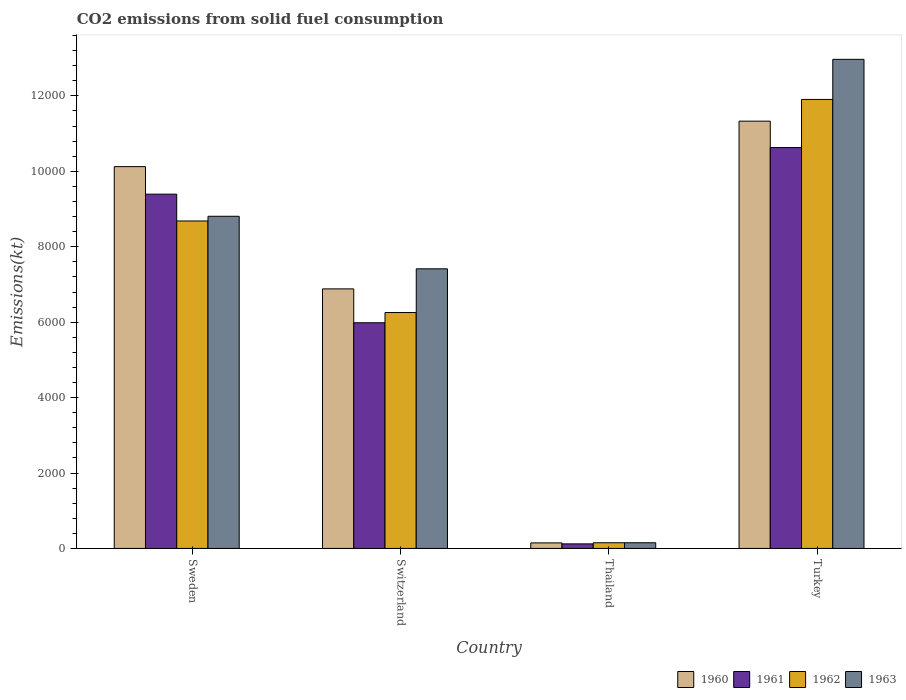How many groups of bars are there?
Offer a very short reply. 4. How many bars are there on the 3rd tick from the right?
Your answer should be very brief. 4. What is the label of the 4th group of bars from the left?
Keep it short and to the point. Turkey. What is the amount of CO2 emitted in 1960 in Thailand?
Keep it short and to the point. 146.68. Across all countries, what is the maximum amount of CO2 emitted in 1961?
Provide a succinct answer. 1.06e+04. Across all countries, what is the minimum amount of CO2 emitted in 1961?
Your answer should be compact. 121.01. In which country was the amount of CO2 emitted in 1961 maximum?
Offer a terse response. Turkey. In which country was the amount of CO2 emitted in 1961 minimum?
Your answer should be compact. Thailand. What is the total amount of CO2 emitted in 1961 in the graph?
Provide a succinct answer. 2.61e+04. What is the difference between the amount of CO2 emitted in 1962 in Switzerland and that in Turkey?
Make the answer very short. -5650.85. What is the difference between the amount of CO2 emitted in 1962 in Switzerland and the amount of CO2 emitted in 1963 in Thailand?
Keep it short and to the point. 6105.55. What is the average amount of CO2 emitted in 1963 per country?
Keep it short and to the point. 7335.83. What is the difference between the amount of CO2 emitted of/in 1960 and amount of CO2 emitted of/in 1962 in Turkey?
Offer a very short reply. -575.72. What is the ratio of the amount of CO2 emitted in 1960 in Sweden to that in Thailand?
Make the answer very short. 69.02. What is the difference between the highest and the second highest amount of CO2 emitted in 1960?
Offer a very short reply. -4448.07. What is the difference between the highest and the lowest amount of CO2 emitted in 1963?
Your answer should be compact. 1.28e+04. In how many countries, is the amount of CO2 emitted in 1960 greater than the average amount of CO2 emitted in 1960 taken over all countries?
Offer a very short reply. 2. How many bars are there?
Your answer should be compact. 16. Are the values on the major ticks of Y-axis written in scientific E-notation?
Give a very brief answer. No. How are the legend labels stacked?
Make the answer very short. Horizontal. What is the title of the graph?
Your answer should be very brief. CO2 emissions from solid fuel consumption. What is the label or title of the Y-axis?
Provide a succinct answer. Emissions(kt). What is the Emissions(kt) in 1960 in Sweden?
Ensure brevity in your answer.  1.01e+04. What is the Emissions(kt) in 1961 in Sweden?
Provide a succinct answer. 9394.85. What is the Emissions(kt) of 1962 in Sweden?
Your response must be concise. 8683.46. What is the Emissions(kt) of 1963 in Sweden?
Provide a succinct answer. 8808.13. What is the Emissions(kt) of 1960 in Switzerland?
Provide a succinct answer. 6882.96. What is the Emissions(kt) of 1961 in Switzerland?
Keep it short and to the point. 5984.54. What is the Emissions(kt) in 1962 in Switzerland?
Your response must be concise. 6255.9. What is the Emissions(kt) of 1963 in Switzerland?
Offer a very short reply. 7414.67. What is the Emissions(kt) in 1960 in Thailand?
Your response must be concise. 146.68. What is the Emissions(kt) in 1961 in Thailand?
Offer a terse response. 121.01. What is the Emissions(kt) in 1962 in Thailand?
Offer a very short reply. 150.35. What is the Emissions(kt) in 1963 in Thailand?
Your answer should be very brief. 150.35. What is the Emissions(kt) in 1960 in Turkey?
Offer a terse response. 1.13e+04. What is the Emissions(kt) of 1961 in Turkey?
Your response must be concise. 1.06e+04. What is the Emissions(kt) of 1962 in Turkey?
Ensure brevity in your answer.  1.19e+04. What is the Emissions(kt) of 1963 in Turkey?
Make the answer very short. 1.30e+04. Across all countries, what is the maximum Emissions(kt) in 1960?
Provide a succinct answer. 1.13e+04. Across all countries, what is the maximum Emissions(kt) of 1961?
Your response must be concise. 1.06e+04. Across all countries, what is the maximum Emissions(kt) of 1962?
Give a very brief answer. 1.19e+04. Across all countries, what is the maximum Emissions(kt) of 1963?
Make the answer very short. 1.30e+04. Across all countries, what is the minimum Emissions(kt) of 1960?
Ensure brevity in your answer.  146.68. Across all countries, what is the minimum Emissions(kt) in 1961?
Offer a very short reply. 121.01. Across all countries, what is the minimum Emissions(kt) in 1962?
Keep it short and to the point. 150.35. Across all countries, what is the minimum Emissions(kt) of 1963?
Your answer should be compact. 150.35. What is the total Emissions(kt) in 1960 in the graph?
Make the answer very short. 2.85e+04. What is the total Emissions(kt) in 1961 in the graph?
Give a very brief answer. 2.61e+04. What is the total Emissions(kt) of 1962 in the graph?
Keep it short and to the point. 2.70e+04. What is the total Emissions(kt) of 1963 in the graph?
Your answer should be very brief. 2.93e+04. What is the difference between the Emissions(kt) of 1960 in Sweden and that in Switzerland?
Keep it short and to the point. 3241.63. What is the difference between the Emissions(kt) in 1961 in Sweden and that in Switzerland?
Your response must be concise. 3410.31. What is the difference between the Emissions(kt) in 1962 in Sweden and that in Switzerland?
Offer a very short reply. 2427.55. What is the difference between the Emissions(kt) of 1963 in Sweden and that in Switzerland?
Your answer should be very brief. 1393.46. What is the difference between the Emissions(kt) of 1960 in Sweden and that in Thailand?
Keep it short and to the point. 9977.91. What is the difference between the Emissions(kt) of 1961 in Sweden and that in Thailand?
Your answer should be very brief. 9273.84. What is the difference between the Emissions(kt) in 1962 in Sweden and that in Thailand?
Make the answer very short. 8533.11. What is the difference between the Emissions(kt) of 1963 in Sweden and that in Thailand?
Ensure brevity in your answer.  8657.79. What is the difference between the Emissions(kt) in 1960 in Sweden and that in Turkey?
Give a very brief answer. -1206.44. What is the difference between the Emissions(kt) in 1961 in Sweden and that in Turkey?
Provide a short and direct response. -1235.78. What is the difference between the Emissions(kt) of 1962 in Sweden and that in Turkey?
Your answer should be very brief. -3223.29. What is the difference between the Emissions(kt) in 1963 in Sweden and that in Turkey?
Ensure brevity in your answer.  -4162.05. What is the difference between the Emissions(kt) of 1960 in Switzerland and that in Thailand?
Give a very brief answer. 6736.28. What is the difference between the Emissions(kt) of 1961 in Switzerland and that in Thailand?
Your answer should be very brief. 5863.53. What is the difference between the Emissions(kt) of 1962 in Switzerland and that in Thailand?
Your answer should be compact. 6105.56. What is the difference between the Emissions(kt) of 1963 in Switzerland and that in Thailand?
Ensure brevity in your answer.  7264.33. What is the difference between the Emissions(kt) of 1960 in Switzerland and that in Turkey?
Keep it short and to the point. -4448.07. What is the difference between the Emissions(kt) of 1961 in Switzerland and that in Turkey?
Your answer should be compact. -4646.09. What is the difference between the Emissions(kt) of 1962 in Switzerland and that in Turkey?
Give a very brief answer. -5650.85. What is the difference between the Emissions(kt) in 1963 in Switzerland and that in Turkey?
Offer a very short reply. -5555.51. What is the difference between the Emissions(kt) of 1960 in Thailand and that in Turkey?
Your answer should be very brief. -1.12e+04. What is the difference between the Emissions(kt) of 1961 in Thailand and that in Turkey?
Provide a succinct answer. -1.05e+04. What is the difference between the Emissions(kt) in 1962 in Thailand and that in Turkey?
Offer a terse response. -1.18e+04. What is the difference between the Emissions(kt) in 1963 in Thailand and that in Turkey?
Ensure brevity in your answer.  -1.28e+04. What is the difference between the Emissions(kt) in 1960 in Sweden and the Emissions(kt) in 1961 in Switzerland?
Give a very brief answer. 4140.04. What is the difference between the Emissions(kt) of 1960 in Sweden and the Emissions(kt) of 1962 in Switzerland?
Give a very brief answer. 3868.68. What is the difference between the Emissions(kt) of 1960 in Sweden and the Emissions(kt) of 1963 in Switzerland?
Keep it short and to the point. 2709.91. What is the difference between the Emissions(kt) in 1961 in Sweden and the Emissions(kt) in 1962 in Switzerland?
Make the answer very short. 3138.95. What is the difference between the Emissions(kt) of 1961 in Sweden and the Emissions(kt) of 1963 in Switzerland?
Ensure brevity in your answer.  1980.18. What is the difference between the Emissions(kt) of 1962 in Sweden and the Emissions(kt) of 1963 in Switzerland?
Make the answer very short. 1268.78. What is the difference between the Emissions(kt) of 1960 in Sweden and the Emissions(kt) of 1961 in Thailand?
Make the answer very short. 1.00e+04. What is the difference between the Emissions(kt) in 1960 in Sweden and the Emissions(kt) in 1962 in Thailand?
Make the answer very short. 9974.24. What is the difference between the Emissions(kt) of 1960 in Sweden and the Emissions(kt) of 1963 in Thailand?
Give a very brief answer. 9974.24. What is the difference between the Emissions(kt) of 1961 in Sweden and the Emissions(kt) of 1962 in Thailand?
Provide a short and direct response. 9244.51. What is the difference between the Emissions(kt) of 1961 in Sweden and the Emissions(kt) of 1963 in Thailand?
Provide a succinct answer. 9244.51. What is the difference between the Emissions(kt) in 1962 in Sweden and the Emissions(kt) in 1963 in Thailand?
Provide a short and direct response. 8533.11. What is the difference between the Emissions(kt) of 1960 in Sweden and the Emissions(kt) of 1961 in Turkey?
Make the answer very short. -506.05. What is the difference between the Emissions(kt) of 1960 in Sweden and the Emissions(kt) of 1962 in Turkey?
Your response must be concise. -1782.16. What is the difference between the Emissions(kt) of 1960 in Sweden and the Emissions(kt) of 1963 in Turkey?
Your answer should be compact. -2845.59. What is the difference between the Emissions(kt) in 1961 in Sweden and the Emissions(kt) in 1962 in Turkey?
Your answer should be very brief. -2511.89. What is the difference between the Emissions(kt) of 1961 in Sweden and the Emissions(kt) of 1963 in Turkey?
Your answer should be very brief. -3575.32. What is the difference between the Emissions(kt) of 1962 in Sweden and the Emissions(kt) of 1963 in Turkey?
Make the answer very short. -4286.72. What is the difference between the Emissions(kt) of 1960 in Switzerland and the Emissions(kt) of 1961 in Thailand?
Your response must be concise. 6761.95. What is the difference between the Emissions(kt) in 1960 in Switzerland and the Emissions(kt) in 1962 in Thailand?
Make the answer very short. 6732.61. What is the difference between the Emissions(kt) in 1960 in Switzerland and the Emissions(kt) in 1963 in Thailand?
Offer a terse response. 6732.61. What is the difference between the Emissions(kt) of 1961 in Switzerland and the Emissions(kt) of 1962 in Thailand?
Your response must be concise. 5834.2. What is the difference between the Emissions(kt) of 1961 in Switzerland and the Emissions(kt) of 1963 in Thailand?
Your response must be concise. 5834.2. What is the difference between the Emissions(kt) in 1962 in Switzerland and the Emissions(kt) in 1963 in Thailand?
Offer a terse response. 6105.56. What is the difference between the Emissions(kt) in 1960 in Switzerland and the Emissions(kt) in 1961 in Turkey?
Your response must be concise. -3747.67. What is the difference between the Emissions(kt) in 1960 in Switzerland and the Emissions(kt) in 1962 in Turkey?
Your answer should be very brief. -5023.79. What is the difference between the Emissions(kt) in 1960 in Switzerland and the Emissions(kt) in 1963 in Turkey?
Make the answer very short. -6087.22. What is the difference between the Emissions(kt) of 1961 in Switzerland and the Emissions(kt) of 1962 in Turkey?
Your answer should be very brief. -5922.2. What is the difference between the Emissions(kt) of 1961 in Switzerland and the Emissions(kt) of 1963 in Turkey?
Offer a terse response. -6985.64. What is the difference between the Emissions(kt) of 1962 in Switzerland and the Emissions(kt) of 1963 in Turkey?
Offer a terse response. -6714.28. What is the difference between the Emissions(kt) in 1960 in Thailand and the Emissions(kt) in 1961 in Turkey?
Your response must be concise. -1.05e+04. What is the difference between the Emissions(kt) of 1960 in Thailand and the Emissions(kt) of 1962 in Turkey?
Your answer should be compact. -1.18e+04. What is the difference between the Emissions(kt) of 1960 in Thailand and the Emissions(kt) of 1963 in Turkey?
Make the answer very short. -1.28e+04. What is the difference between the Emissions(kt) in 1961 in Thailand and the Emissions(kt) in 1962 in Turkey?
Give a very brief answer. -1.18e+04. What is the difference between the Emissions(kt) of 1961 in Thailand and the Emissions(kt) of 1963 in Turkey?
Provide a short and direct response. -1.28e+04. What is the difference between the Emissions(kt) of 1962 in Thailand and the Emissions(kt) of 1963 in Turkey?
Give a very brief answer. -1.28e+04. What is the average Emissions(kt) of 1960 per country?
Ensure brevity in your answer.  7121.31. What is the average Emissions(kt) in 1961 per country?
Keep it short and to the point. 6532.76. What is the average Emissions(kt) of 1962 per country?
Give a very brief answer. 6749.11. What is the average Emissions(kt) in 1963 per country?
Offer a very short reply. 7335.83. What is the difference between the Emissions(kt) in 1960 and Emissions(kt) in 1961 in Sweden?
Your response must be concise. 729.73. What is the difference between the Emissions(kt) in 1960 and Emissions(kt) in 1962 in Sweden?
Keep it short and to the point. 1441.13. What is the difference between the Emissions(kt) in 1960 and Emissions(kt) in 1963 in Sweden?
Offer a very short reply. 1316.45. What is the difference between the Emissions(kt) of 1961 and Emissions(kt) of 1962 in Sweden?
Your response must be concise. 711.4. What is the difference between the Emissions(kt) in 1961 and Emissions(kt) in 1963 in Sweden?
Your answer should be very brief. 586.72. What is the difference between the Emissions(kt) of 1962 and Emissions(kt) of 1963 in Sweden?
Provide a short and direct response. -124.68. What is the difference between the Emissions(kt) in 1960 and Emissions(kt) in 1961 in Switzerland?
Offer a very short reply. 898.41. What is the difference between the Emissions(kt) in 1960 and Emissions(kt) in 1962 in Switzerland?
Provide a succinct answer. 627.06. What is the difference between the Emissions(kt) in 1960 and Emissions(kt) in 1963 in Switzerland?
Provide a succinct answer. -531.72. What is the difference between the Emissions(kt) in 1961 and Emissions(kt) in 1962 in Switzerland?
Provide a short and direct response. -271.36. What is the difference between the Emissions(kt) in 1961 and Emissions(kt) in 1963 in Switzerland?
Your answer should be compact. -1430.13. What is the difference between the Emissions(kt) in 1962 and Emissions(kt) in 1963 in Switzerland?
Your answer should be compact. -1158.77. What is the difference between the Emissions(kt) of 1960 and Emissions(kt) of 1961 in Thailand?
Your response must be concise. 25.67. What is the difference between the Emissions(kt) in 1960 and Emissions(kt) in 1962 in Thailand?
Provide a short and direct response. -3.67. What is the difference between the Emissions(kt) of 1960 and Emissions(kt) of 1963 in Thailand?
Make the answer very short. -3.67. What is the difference between the Emissions(kt) of 1961 and Emissions(kt) of 1962 in Thailand?
Keep it short and to the point. -29.34. What is the difference between the Emissions(kt) of 1961 and Emissions(kt) of 1963 in Thailand?
Offer a terse response. -29.34. What is the difference between the Emissions(kt) in 1960 and Emissions(kt) in 1961 in Turkey?
Offer a terse response. 700.4. What is the difference between the Emissions(kt) in 1960 and Emissions(kt) in 1962 in Turkey?
Your answer should be compact. -575.72. What is the difference between the Emissions(kt) of 1960 and Emissions(kt) of 1963 in Turkey?
Ensure brevity in your answer.  -1639.15. What is the difference between the Emissions(kt) in 1961 and Emissions(kt) in 1962 in Turkey?
Provide a short and direct response. -1276.12. What is the difference between the Emissions(kt) of 1961 and Emissions(kt) of 1963 in Turkey?
Keep it short and to the point. -2339.55. What is the difference between the Emissions(kt) of 1962 and Emissions(kt) of 1963 in Turkey?
Your response must be concise. -1063.43. What is the ratio of the Emissions(kt) in 1960 in Sweden to that in Switzerland?
Provide a short and direct response. 1.47. What is the ratio of the Emissions(kt) in 1961 in Sweden to that in Switzerland?
Your answer should be compact. 1.57. What is the ratio of the Emissions(kt) in 1962 in Sweden to that in Switzerland?
Make the answer very short. 1.39. What is the ratio of the Emissions(kt) in 1963 in Sweden to that in Switzerland?
Your answer should be very brief. 1.19. What is the ratio of the Emissions(kt) in 1960 in Sweden to that in Thailand?
Ensure brevity in your answer.  69.03. What is the ratio of the Emissions(kt) in 1961 in Sweden to that in Thailand?
Ensure brevity in your answer.  77.64. What is the ratio of the Emissions(kt) in 1962 in Sweden to that in Thailand?
Ensure brevity in your answer.  57.76. What is the ratio of the Emissions(kt) of 1963 in Sweden to that in Thailand?
Make the answer very short. 58.59. What is the ratio of the Emissions(kt) of 1960 in Sweden to that in Turkey?
Keep it short and to the point. 0.89. What is the ratio of the Emissions(kt) in 1961 in Sweden to that in Turkey?
Your answer should be compact. 0.88. What is the ratio of the Emissions(kt) of 1962 in Sweden to that in Turkey?
Your answer should be compact. 0.73. What is the ratio of the Emissions(kt) in 1963 in Sweden to that in Turkey?
Ensure brevity in your answer.  0.68. What is the ratio of the Emissions(kt) in 1960 in Switzerland to that in Thailand?
Provide a short and direct response. 46.92. What is the ratio of the Emissions(kt) of 1961 in Switzerland to that in Thailand?
Keep it short and to the point. 49.45. What is the ratio of the Emissions(kt) of 1962 in Switzerland to that in Thailand?
Offer a very short reply. 41.61. What is the ratio of the Emissions(kt) in 1963 in Switzerland to that in Thailand?
Provide a succinct answer. 49.32. What is the ratio of the Emissions(kt) of 1960 in Switzerland to that in Turkey?
Your response must be concise. 0.61. What is the ratio of the Emissions(kt) in 1961 in Switzerland to that in Turkey?
Make the answer very short. 0.56. What is the ratio of the Emissions(kt) in 1962 in Switzerland to that in Turkey?
Give a very brief answer. 0.53. What is the ratio of the Emissions(kt) in 1963 in Switzerland to that in Turkey?
Your response must be concise. 0.57. What is the ratio of the Emissions(kt) in 1960 in Thailand to that in Turkey?
Your answer should be very brief. 0.01. What is the ratio of the Emissions(kt) in 1961 in Thailand to that in Turkey?
Provide a short and direct response. 0.01. What is the ratio of the Emissions(kt) in 1962 in Thailand to that in Turkey?
Make the answer very short. 0.01. What is the ratio of the Emissions(kt) in 1963 in Thailand to that in Turkey?
Your answer should be compact. 0.01. What is the difference between the highest and the second highest Emissions(kt) of 1960?
Provide a succinct answer. 1206.44. What is the difference between the highest and the second highest Emissions(kt) in 1961?
Ensure brevity in your answer.  1235.78. What is the difference between the highest and the second highest Emissions(kt) of 1962?
Your answer should be compact. 3223.29. What is the difference between the highest and the second highest Emissions(kt) in 1963?
Provide a succinct answer. 4162.05. What is the difference between the highest and the lowest Emissions(kt) of 1960?
Make the answer very short. 1.12e+04. What is the difference between the highest and the lowest Emissions(kt) of 1961?
Provide a succinct answer. 1.05e+04. What is the difference between the highest and the lowest Emissions(kt) in 1962?
Give a very brief answer. 1.18e+04. What is the difference between the highest and the lowest Emissions(kt) in 1963?
Your answer should be compact. 1.28e+04. 